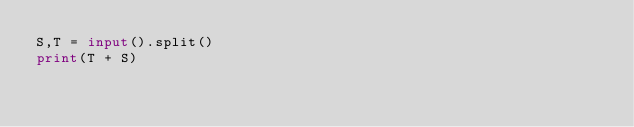<code> <loc_0><loc_0><loc_500><loc_500><_Python_>S,T = input().split()
print(T + S)</code> 